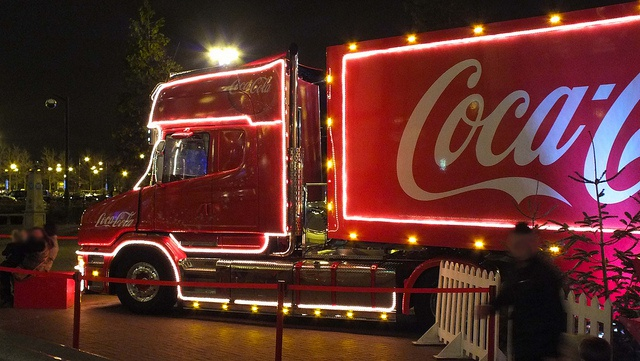Describe the objects in this image and their specific colors. I can see truck in black, maroon, brown, and white tones, people in black, maroon, and gray tones, people in black, maroon, and brown tones, and people in black and maroon tones in this image. 